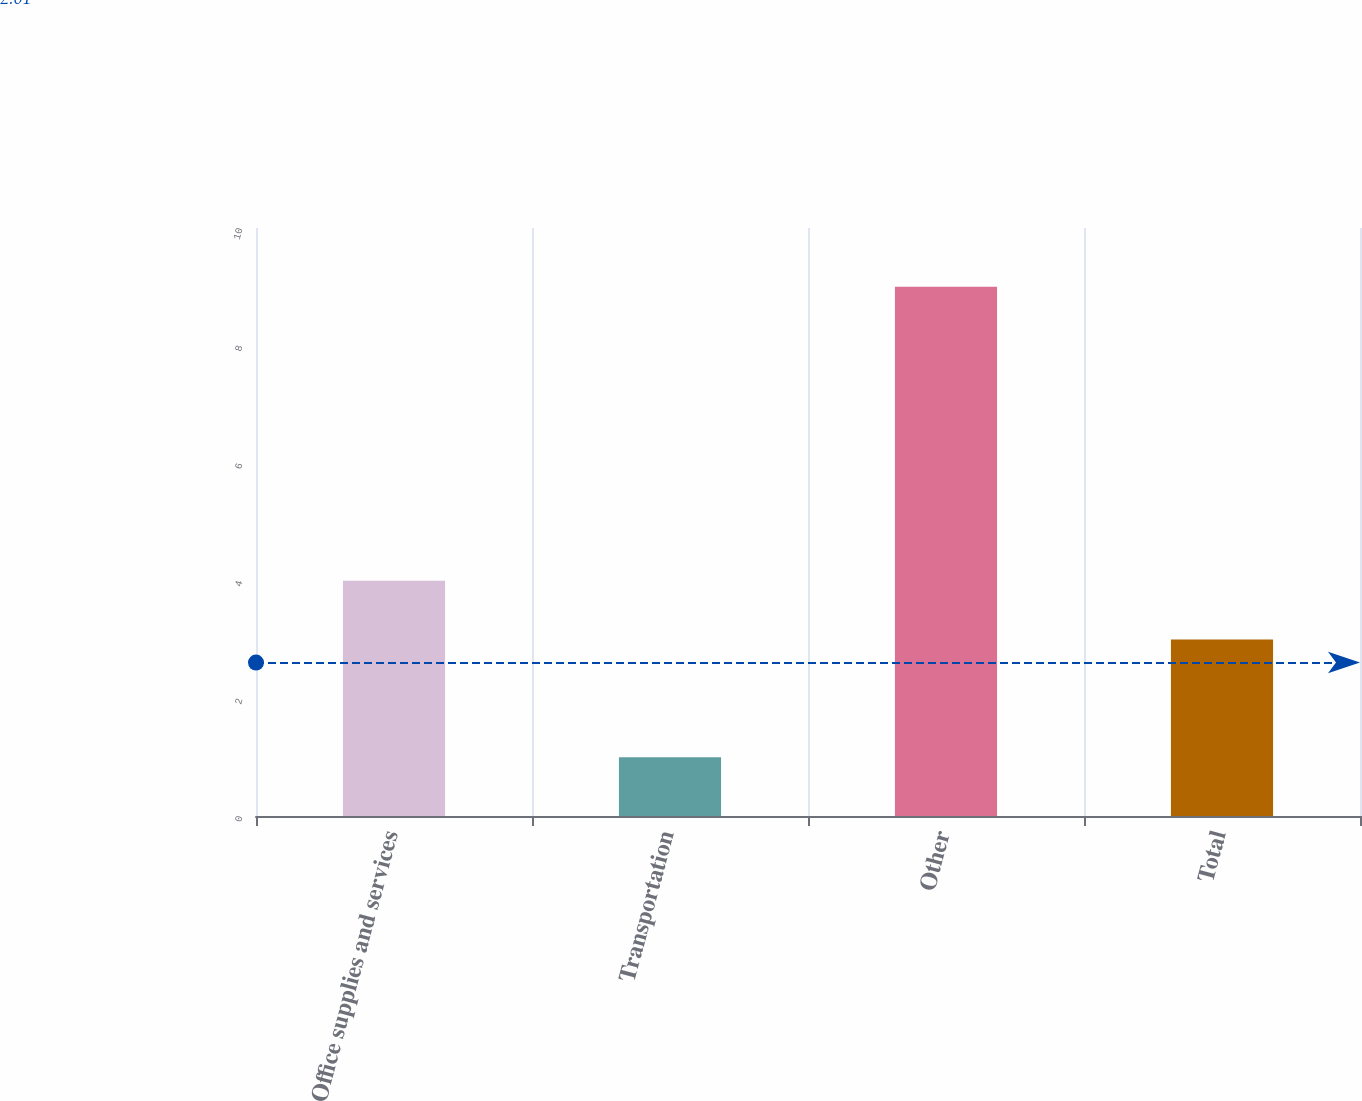Convert chart. <chart><loc_0><loc_0><loc_500><loc_500><bar_chart><fcel>Office supplies and services<fcel>Transportation<fcel>Other<fcel>Total<nl><fcel>4<fcel>1<fcel>9<fcel>3<nl></chart> 